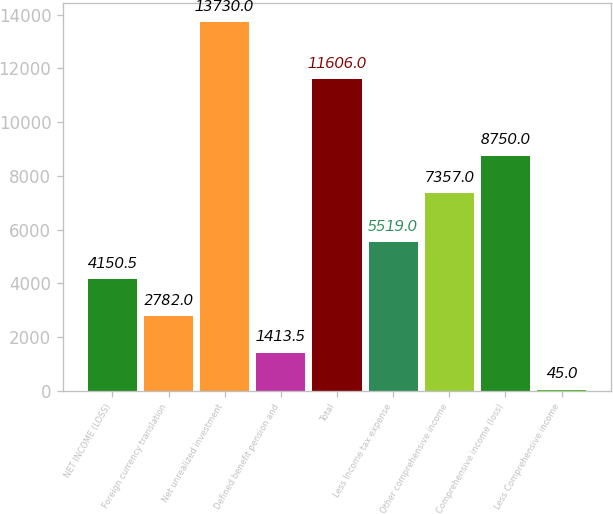Convert chart. <chart><loc_0><loc_0><loc_500><loc_500><bar_chart><fcel>NET INCOME (LOSS)<fcel>Foreign currency translation<fcel>Net unrealized investment<fcel>Defined benefit pension and<fcel>Total<fcel>Less Income tax expense<fcel>Other comprehensive income<fcel>Comprehensive income (loss)<fcel>Less Comprehensive income<nl><fcel>4150.5<fcel>2782<fcel>13730<fcel>1413.5<fcel>11606<fcel>5519<fcel>7357<fcel>8750<fcel>45<nl></chart> 